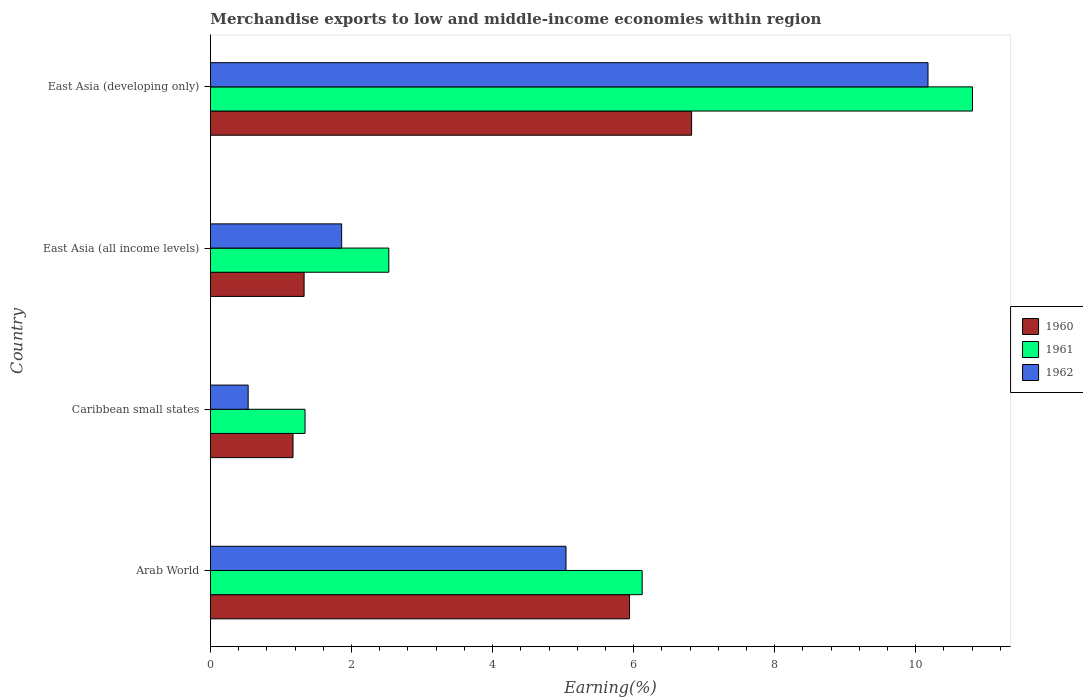How many different coloured bars are there?
Ensure brevity in your answer.  3. How many groups of bars are there?
Provide a succinct answer. 4. What is the label of the 1st group of bars from the top?
Provide a succinct answer. East Asia (developing only). In how many cases, is the number of bars for a given country not equal to the number of legend labels?
Provide a short and direct response. 0. What is the percentage of amount earned from merchandise exports in 1960 in East Asia (all income levels)?
Your response must be concise. 1.33. Across all countries, what is the maximum percentage of amount earned from merchandise exports in 1960?
Give a very brief answer. 6.82. Across all countries, what is the minimum percentage of amount earned from merchandise exports in 1960?
Provide a succinct answer. 1.17. In which country was the percentage of amount earned from merchandise exports in 1961 maximum?
Your response must be concise. East Asia (developing only). In which country was the percentage of amount earned from merchandise exports in 1960 minimum?
Provide a short and direct response. Caribbean small states. What is the total percentage of amount earned from merchandise exports in 1961 in the graph?
Your answer should be very brief. 20.79. What is the difference between the percentage of amount earned from merchandise exports in 1962 in Caribbean small states and that in East Asia (all income levels)?
Offer a very short reply. -1.33. What is the difference between the percentage of amount earned from merchandise exports in 1960 in Caribbean small states and the percentage of amount earned from merchandise exports in 1961 in East Asia (developing only)?
Your response must be concise. -9.63. What is the average percentage of amount earned from merchandise exports in 1962 per country?
Your answer should be very brief. 4.4. What is the difference between the percentage of amount earned from merchandise exports in 1962 and percentage of amount earned from merchandise exports in 1961 in East Asia (developing only)?
Your answer should be very brief. -0.63. In how many countries, is the percentage of amount earned from merchandise exports in 1960 greater than 8.4 %?
Offer a very short reply. 0. What is the ratio of the percentage of amount earned from merchandise exports in 1961 in Caribbean small states to that in East Asia (all income levels)?
Your answer should be very brief. 0.53. Is the percentage of amount earned from merchandise exports in 1962 in Arab World less than that in East Asia (all income levels)?
Your answer should be very brief. No. What is the difference between the highest and the second highest percentage of amount earned from merchandise exports in 1961?
Your answer should be compact. 4.68. What is the difference between the highest and the lowest percentage of amount earned from merchandise exports in 1962?
Offer a very short reply. 9.64. What does the 2nd bar from the top in East Asia (developing only) represents?
Offer a very short reply. 1961. What does the 2nd bar from the bottom in Arab World represents?
Offer a terse response. 1961. Is it the case that in every country, the sum of the percentage of amount earned from merchandise exports in 1960 and percentage of amount earned from merchandise exports in 1961 is greater than the percentage of amount earned from merchandise exports in 1962?
Provide a succinct answer. Yes. How many bars are there?
Your answer should be very brief. 12. Are all the bars in the graph horizontal?
Make the answer very short. Yes. Are the values on the major ticks of X-axis written in scientific E-notation?
Provide a short and direct response. No. Does the graph contain any zero values?
Your response must be concise. No. Where does the legend appear in the graph?
Give a very brief answer. Center right. How many legend labels are there?
Provide a succinct answer. 3. How are the legend labels stacked?
Keep it short and to the point. Vertical. What is the title of the graph?
Keep it short and to the point. Merchandise exports to low and middle-income economies within region. What is the label or title of the X-axis?
Offer a very short reply. Earning(%). What is the Earning(%) in 1960 in Arab World?
Your response must be concise. 5.94. What is the Earning(%) of 1961 in Arab World?
Provide a succinct answer. 6.12. What is the Earning(%) of 1962 in Arab World?
Offer a very short reply. 5.04. What is the Earning(%) in 1960 in Caribbean small states?
Keep it short and to the point. 1.17. What is the Earning(%) in 1961 in Caribbean small states?
Your response must be concise. 1.34. What is the Earning(%) in 1962 in Caribbean small states?
Make the answer very short. 0.53. What is the Earning(%) of 1960 in East Asia (all income levels)?
Your response must be concise. 1.33. What is the Earning(%) of 1961 in East Asia (all income levels)?
Keep it short and to the point. 2.53. What is the Earning(%) in 1962 in East Asia (all income levels)?
Ensure brevity in your answer.  1.86. What is the Earning(%) in 1960 in East Asia (developing only)?
Provide a short and direct response. 6.82. What is the Earning(%) of 1961 in East Asia (developing only)?
Your response must be concise. 10.8. What is the Earning(%) of 1962 in East Asia (developing only)?
Your response must be concise. 10.17. Across all countries, what is the maximum Earning(%) in 1960?
Offer a very short reply. 6.82. Across all countries, what is the maximum Earning(%) in 1961?
Your response must be concise. 10.8. Across all countries, what is the maximum Earning(%) of 1962?
Your answer should be compact. 10.17. Across all countries, what is the minimum Earning(%) of 1960?
Your response must be concise. 1.17. Across all countries, what is the minimum Earning(%) in 1961?
Provide a short and direct response. 1.34. Across all countries, what is the minimum Earning(%) of 1962?
Your answer should be very brief. 0.53. What is the total Earning(%) of 1960 in the graph?
Provide a succinct answer. 15.26. What is the total Earning(%) of 1961 in the graph?
Provide a succinct answer. 20.8. What is the total Earning(%) in 1962 in the graph?
Give a very brief answer. 17.61. What is the difference between the Earning(%) of 1960 in Arab World and that in Caribbean small states?
Your answer should be very brief. 4.77. What is the difference between the Earning(%) of 1961 in Arab World and that in Caribbean small states?
Your response must be concise. 4.78. What is the difference between the Earning(%) in 1962 in Arab World and that in Caribbean small states?
Offer a terse response. 4.51. What is the difference between the Earning(%) in 1960 in Arab World and that in East Asia (all income levels)?
Provide a succinct answer. 4.61. What is the difference between the Earning(%) of 1961 in Arab World and that in East Asia (all income levels)?
Offer a terse response. 3.59. What is the difference between the Earning(%) of 1962 in Arab World and that in East Asia (all income levels)?
Give a very brief answer. 3.18. What is the difference between the Earning(%) in 1960 in Arab World and that in East Asia (developing only)?
Provide a short and direct response. -0.88. What is the difference between the Earning(%) in 1961 in Arab World and that in East Asia (developing only)?
Your response must be concise. -4.68. What is the difference between the Earning(%) in 1962 in Arab World and that in East Asia (developing only)?
Provide a succinct answer. -5.13. What is the difference between the Earning(%) in 1960 in Caribbean small states and that in East Asia (all income levels)?
Provide a succinct answer. -0.16. What is the difference between the Earning(%) in 1961 in Caribbean small states and that in East Asia (all income levels)?
Offer a terse response. -1.19. What is the difference between the Earning(%) in 1962 in Caribbean small states and that in East Asia (all income levels)?
Your answer should be very brief. -1.33. What is the difference between the Earning(%) in 1960 in Caribbean small states and that in East Asia (developing only)?
Keep it short and to the point. -5.65. What is the difference between the Earning(%) in 1961 in Caribbean small states and that in East Asia (developing only)?
Provide a short and direct response. -9.46. What is the difference between the Earning(%) of 1962 in Caribbean small states and that in East Asia (developing only)?
Offer a very short reply. -9.64. What is the difference between the Earning(%) of 1960 in East Asia (all income levels) and that in East Asia (developing only)?
Provide a succinct answer. -5.49. What is the difference between the Earning(%) in 1961 in East Asia (all income levels) and that in East Asia (developing only)?
Offer a terse response. -8.28. What is the difference between the Earning(%) in 1962 in East Asia (all income levels) and that in East Asia (developing only)?
Provide a short and direct response. -8.31. What is the difference between the Earning(%) of 1960 in Arab World and the Earning(%) of 1961 in Caribbean small states?
Provide a short and direct response. 4.6. What is the difference between the Earning(%) in 1960 in Arab World and the Earning(%) in 1962 in Caribbean small states?
Give a very brief answer. 5.41. What is the difference between the Earning(%) in 1961 in Arab World and the Earning(%) in 1962 in Caribbean small states?
Keep it short and to the point. 5.59. What is the difference between the Earning(%) of 1960 in Arab World and the Earning(%) of 1961 in East Asia (all income levels)?
Make the answer very short. 3.41. What is the difference between the Earning(%) of 1960 in Arab World and the Earning(%) of 1962 in East Asia (all income levels)?
Keep it short and to the point. 4.08. What is the difference between the Earning(%) in 1961 in Arab World and the Earning(%) in 1962 in East Asia (all income levels)?
Provide a short and direct response. 4.26. What is the difference between the Earning(%) of 1960 in Arab World and the Earning(%) of 1961 in East Asia (developing only)?
Keep it short and to the point. -4.86. What is the difference between the Earning(%) in 1960 in Arab World and the Earning(%) in 1962 in East Asia (developing only)?
Your answer should be very brief. -4.23. What is the difference between the Earning(%) of 1961 in Arab World and the Earning(%) of 1962 in East Asia (developing only)?
Your answer should be very brief. -4.05. What is the difference between the Earning(%) in 1960 in Caribbean small states and the Earning(%) in 1961 in East Asia (all income levels)?
Your answer should be very brief. -1.36. What is the difference between the Earning(%) of 1960 in Caribbean small states and the Earning(%) of 1962 in East Asia (all income levels)?
Your answer should be compact. -0.69. What is the difference between the Earning(%) of 1961 in Caribbean small states and the Earning(%) of 1962 in East Asia (all income levels)?
Your answer should be compact. -0.52. What is the difference between the Earning(%) of 1960 in Caribbean small states and the Earning(%) of 1961 in East Asia (developing only)?
Give a very brief answer. -9.63. What is the difference between the Earning(%) of 1960 in Caribbean small states and the Earning(%) of 1962 in East Asia (developing only)?
Your answer should be compact. -9. What is the difference between the Earning(%) of 1961 in Caribbean small states and the Earning(%) of 1962 in East Asia (developing only)?
Provide a succinct answer. -8.83. What is the difference between the Earning(%) in 1960 in East Asia (all income levels) and the Earning(%) in 1961 in East Asia (developing only)?
Ensure brevity in your answer.  -9.48. What is the difference between the Earning(%) in 1960 in East Asia (all income levels) and the Earning(%) in 1962 in East Asia (developing only)?
Give a very brief answer. -8.85. What is the difference between the Earning(%) in 1961 in East Asia (all income levels) and the Earning(%) in 1962 in East Asia (developing only)?
Ensure brevity in your answer.  -7.65. What is the average Earning(%) in 1960 per country?
Make the answer very short. 3.82. What is the average Earning(%) of 1961 per country?
Your answer should be very brief. 5.2. What is the average Earning(%) in 1962 per country?
Ensure brevity in your answer.  4.4. What is the difference between the Earning(%) in 1960 and Earning(%) in 1961 in Arab World?
Keep it short and to the point. -0.18. What is the difference between the Earning(%) of 1960 and Earning(%) of 1962 in Arab World?
Provide a short and direct response. 0.9. What is the difference between the Earning(%) of 1961 and Earning(%) of 1962 in Arab World?
Your response must be concise. 1.08. What is the difference between the Earning(%) in 1960 and Earning(%) in 1961 in Caribbean small states?
Your response must be concise. -0.17. What is the difference between the Earning(%) of 1960 and Earning(%) of 1962 in Caribbean small states?
Provide a succinct answer. 0.64. What is the difference between the Earning(%) in 1961 and Earning(%) in 1962 in Caribbean small states?
Ensure brevity in your answer.  0.81. What is the difference between the Earning(%) in 1960 and Earning(%) in 1961 in East Asia (all income levels)?
Your response must be concise. -1.2. What is the difference between the Earning(%) of 1960 and Earning(%) of 1962 in East Asia (all income levels)?
Your response must be concise. -0.53. What is the difference between the Earning(%) of 1961 and Earning(%) of 1962 in East Asia (all income levels)?
Offer a very short reply. 0.67. What is the difference between the Earning(%) of 1960 and Earning(%) of 1961 in East Asia (developing only)?
Offer a very short reply. -3.98. What is the difference between the Earning(%) in 1960 and Earning(%) in 1962 in East Asia (developing only)?
Provide a succinct answer. -3.35. What is the difference between the Earning(%) in 1961 and Earning(%) in 1962 in East Asia (developing only)?
Offer a terse response. 0.63. What is the ratio of the Earning(%) of 1960 in Arab World to that in Caribbean small states?
Provide a succinct answer. 5.08. What is the ratio of the Earning(%) of 1961 in Arab World to that in Caribbean small states?
Your answer should be very brief. 4.57. What is the ratio of the Earning(%) in 1962 in Arab World to that in Caribbean small states?
Make the answer very short. 9.44. What is the ratio of the Earning(%) in 1960 in Arab World to that in East Asia (all income levels)?
Your response must be concise. 4.48. What is the ratio of the Earning(%) in 1961 in Arab World to that in East Asia (all income levels)?
Your answer should be compact. 2.42. What is the ratio of the Earning(%) in 1962 in Arab World to that in East Asia (all income levels)?
Make the answer very short. 2.71. What is the ratio of the Earning(%) of 1960 in Arab World to that in East Asia (developing only)?
Make the answer very short. 0.87. What is the ratio of the Earning(%) in 1961 in Arab World to that in East Asia (developing only)?
Keep it short and to the point. 0.57. What is the ratio of the Earning(%) of 1962 in Arab World to that in East Asia (developing only)?
Keep it short and to the point. 0.5. What is the ratio of the Earning(%) of 1960 in Caribbean small states to that in East Asia (all income levels)?
Give a very brief answer. 0.88. What is the ratio of the Earning(%) in 1961 in Caribbean small states to that in East Asia (all income levels)?
Offer a very short reply. 0.53. What is the ratio of the Earning(%) of 1962 in Caribbean small states to that in East Asia (all income levels)?
Your answer should be compact. 0.29. What is the ratio of the Earning(%) of 1960 in Caribbean small states to that in East Asia (developing only)?
Offer a very short reply. 0.17. What is the ratio of the Earning(%) in 1961 in Caribbean small states to that in East Asia (developing only)?
Ensure brevity in your answer.  0.12. What is the ratio of the Earning(%) in 1962 in Caribbean small states to that in East Asia (developing only)?
Provide a short and direct response. 0.05. What is the ratio of the Earning(%) in 1960 in East Asia (all income levels) to that in East Asia (developing only)?
Your answer should be compact. 0.19. What is the ratio of the Earning(%) of 1961 in East Asia (all income levels) to that in East Asia (developing only)?
Your response must be concise. 0.23. What is the ratio of the Earning(%) of 1962 in East Asia (all income levels) to that in East Asia (developing only)?
Offer a terse response. 0.18. What is the difference between the highest and the second highest Earning(%) in 1960?
Offer a terse response. 0.88. What is the difference between the highest and the second highest Earning(%) in 1961?
Your answer should be very brief. 4.68. What is the difference between the highest and the second highest Earning(%) in 1962?
Provide a short and direct response. 5.13. What is the difference between the highest and the lowest Earning(%) in 1960?
Your answer should be compact. 5.65. What is the difference between the highest and the lowest Earning(%) of 1961?
Your answer should be compact. 9.46. What is the difference between the highest and the lowest Earning(%) of 1962?
Offer a terse response. 9.64. 